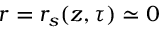<formula> <loc_0><loc_0><loc_500><loc_500>r = r _ { s } ( z , \tau ) \simeq 0</formula> 